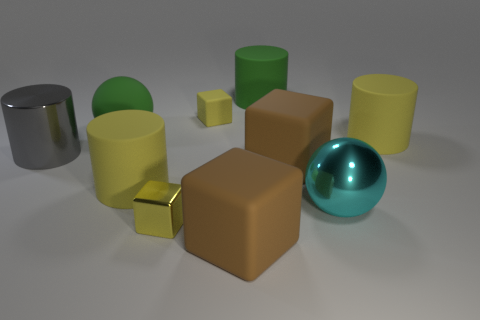Can you tell me what the largest object in the image is, and describe its surface texture? The largest object in the image is a brown cube, and it has a matte surface texture that doesn't reflect light as much as some of the shinier objects. 